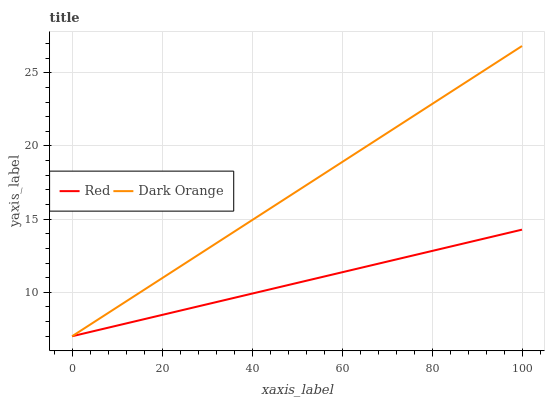Does Red have the minimum area under the curve?
Answer yes or no. Yes. Does Dark Orange have the maximum area under the curve?
Answer yes or no. Yes. Does Red have the maximum area under the curve?
Answer yes or no. No. Is Red the smoothest?
Answer yes or no. Yes. Is Dark Orange the roughest?
Answer yes or no. Yes. Is Red the roughest?
Answer yes or no. No. Does Dark Orange have the lowest value?
Answer yes or no. Yes. Does Dark Orange have the highest value?
Answer yes or no. Yes. Does Red have the highest value?
Answer yes or no. No. Does Dark Orange intersect Red?
Answer yes or no. Yes. Is Dark Orange less than Red?
Answer yes or no. No. Is Dark Orange greater than Red?
Answer yes or no. No. 